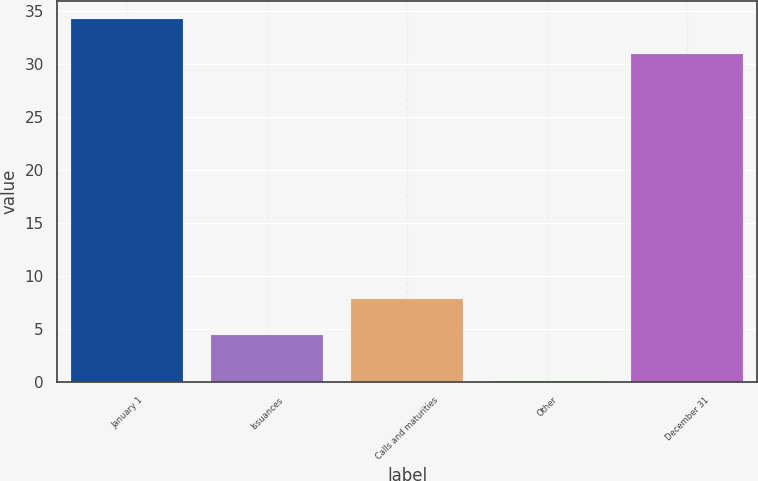<chart> <loc_0><loc_0><loc_500><loc_500><bar_chart><fcel>January 1<fcel>Issuances<fcel>Calls and maturities<fcel>Other<fcel>December 31<nl><fcel>34.22<fcel>4.5<fcel>7.82<fcel>0.1<fcel>30.9<nl></chart> 